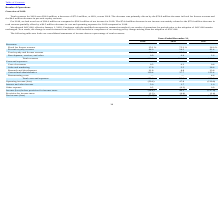According to Immersion's financial document, Why was there a decrease in total revenues in 2019? driven by the $70.9 million decrease in fixed fee license revenue and the $4.0 million decrease in per-unit royalty revenue.. The document states: "n, or 68%, versus 2018. The decrease was primarily driven by the $70.9 million decrease in fixed fee license revenue and the $4.0 million decrease in ..." Also, What was the decrease in total revenues from 2018 to 2019? According to the financial document, $75.0 million. The relevant text states: "evenues for 2019 were $36.0 million, a decrease of $75.0 million, or 68%, versus 2018. The decrease was primarily driven by the $70.9 million decrease in fixed fee..." Also, What led to $74.4 million decrease in net income? the $75.0 million decrease in total revenue partially offset by a $0.5 million decrease in cost and operating expenses for 2019 compared to 2018.. The document states: "llion decrease in net income was mainly related to the $75.0 million decrease in total revenue partially offset by a $0.5 million decrease in cost and..." Also, can you calculate: What is the change in Fixed fee license revenue from 2018 and 2019? Based on the calculation: 35.1-75.3, the result is -40.2 (percentage). This is based on the information: "Fixed fee license revenue 35.1 % 75.3 % 36.0 % Fixed fee license revenue 35.1 % 75.3 % 36.0 %..." The key data points involved are: 35.1, 75.3. Also, can you calculate: What is the change in Per-unit royalty revenue between 2018 and 2019? Based on the calculation: 64.0-24.3, the result is 39.7 (percentage). This is based on the information: "Per-unit royalty revenue 64.0 24.3 61.4 Per-unit royalty revenue 64.0 24.3 61.4..." The key data points involved are: 24.3, 64.0. Also, can you calculate: What is the average Fixed fee license revenue for 2018 and 2019? To answer this question, I need to perform calculations using the financial data. The calculation is: (35.1+75.3) / 2, which equals 55.2 (percentage). This is based on the information: "Fixed fee license revenue 35.1 % 75.3 % 36.0 % Fixed fee license revenue 35.1 % 75.3 % 36.0 %..." The key data points involved are: 35.1, 75.3. 